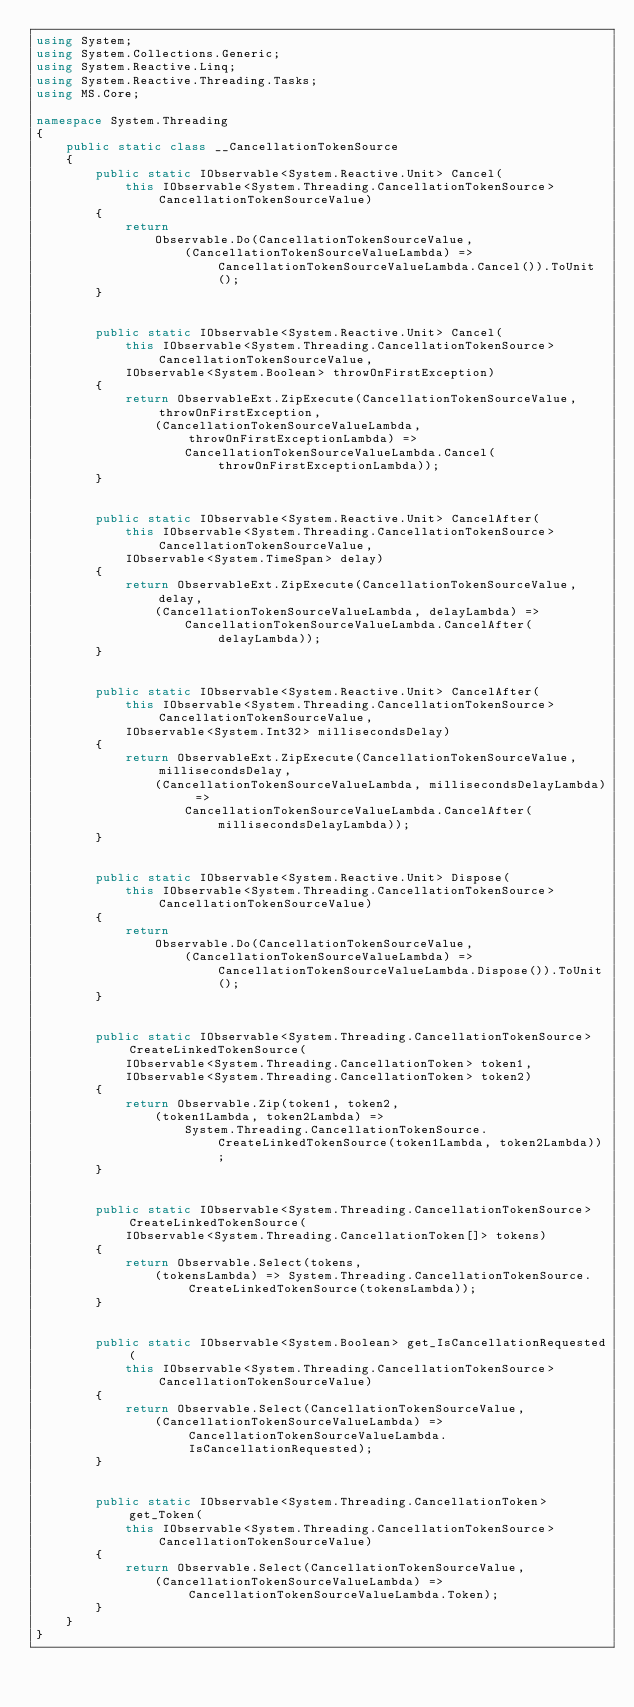Convert code to text. <code><loc_0><loc_0><loc_500><loc_500><_C#_>using System;
using System.Collections.Generic;
using System.Reactive.Linq;
using System.Reactive.Threading.Tasks;
using MS.Core;

namespace System.Threading
{
    public static class __CancellationTokenSource
    {
        public static IObservable<System.Reactive.Unit> Cancel(
            this IObservable<System.Threading.CancellationTokenSource> CancellationTokenSourceValue)
        {
            return
                Observable.Do(CancellationTokenSourceValue,
                    (CancellationTokenSourceValueLambda) => CancellationTokenSourceValueLambda.Cancel()).ToUnit();
        }


        public static IObservable<System.Reactive.Unit> Cancel(
            this IObservable<System.Threading.CancellationTokenSource> CancellationTokenSourceValue,
            IObservable<System.Boolean> throwOnFirstException)
        {
            return ObservableExt.ZipExecute(CancellationTokenSourceValue, throwOnFirstException,
                (CancellationTokenSourceValueLambda, throwOnFirstExceptionLambda) =>
                    CancellationTokenSourceValueLambda.Cancel(throwOnFirstExceptionLambda));
        }


        public static IObservable<System.Reactive.Unit> CancelAfter(
            this IObservable<System.Threading.CancellationTokenSource> CancellationTokenSourceValue,
            IObservable<System.TimeSpan> delay)
        {
            return ObservableExt.ZipExecute(CancellationTokenSourceValue, delay,
                (CancellationTokenSourceValueLambda, delayLambda) =>
                    CancellationTokenSourceValueLambda.CancelAfter(delayLambda));
        }


        public static IObservable<System.Reactive.Unit> CancelAfter(
            this IObservable<System.Threading.CancellationTokenSource> CancellationTokenSourceValue,
            IObservable<System.Int32> millisecondsDelay)
        {
            return ObservableExt.ZipExecute(CancellationTokenSourceValue, millisecondsDelay,
                (CancellationTokenSourceValueLambda, millisecondsDelayLambda) =>
                    CancellationTokenSourceValueLambda.CancelAfter(millisecondsDelayLambda));
        }


        public static IObservable<System.Reactive.Unit> Dispose(
            this IObservable<System.Threading.CancellationTokenSource> CancellationTokenSourceValue)
        {
            return
                Observable.Do(CancellationTokenSourceValue,
                    (CancellationTokenSourceValueLambda) => CancellationTokenSourceValueLambda.Dispose()).ToUnit();
        }


        public static IObservable<System.Threading.CancellationTokenSource> CreateLinkedTokenSource(
            IObservable<System.Threading.CancellationToken> token1,
            IObservable<System.Threading.CancellationToken> token2)
        {
            return Observable.Zip(token1, token2,
                (token1Lambda, token2Lambda) =>
                    System.Threading.CancellationTokenSource.CreateLinkedTokenSource(token1Lambda, token2Lambda));
        }


        public static IObservable<System.Threading.CancellationTokenSource> CreateLinkedTokenSource(
            IObservable<System.Threading.CancellationToken[]> tokens)
        {
            return Observable.Select(tokens,
                (tokensLambda) => System.Threading.CancellationTokenSource.CreateLinkedTokenSource(tokensLambda));
        }


        public static IObservable<System.Boolean> get_IsCancellationRequested(
            this IObservable<System.Threading.CancellationTokenSource> CancellationTokenSourceValue)
        {
            return Observable.Select(CancellationTokenSourceValue,
                (CancellationTokenSourceValueLambda) => CancellationTokenSourceValueLambda.IsCancellationRequested);
        }


        public static IObservable<System.Threading.CancellationToken> get_Token(
            this IObservable<System.Threading.CancellationTokenSource> CancellationTokenSourceValue)
        {
            return Observable.Select(CancellationTokenSourceValue,
                (CancellationTokenSourceValueLambda) => CancellationTokenSourceValueLambda.Token);
        }
    }
}</code> 